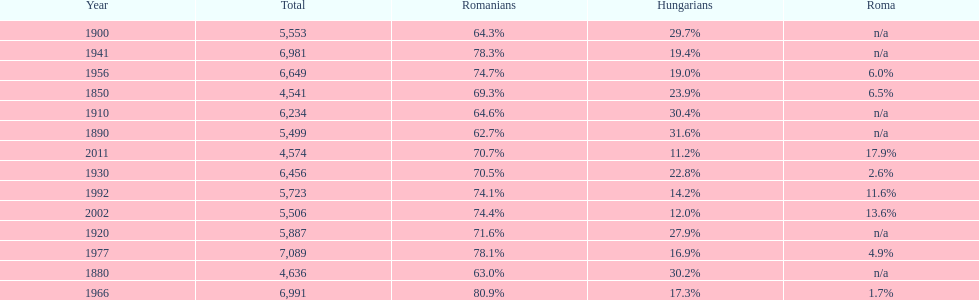Which year had a total of 6,981 and 19.4% hungarians? 1941. 